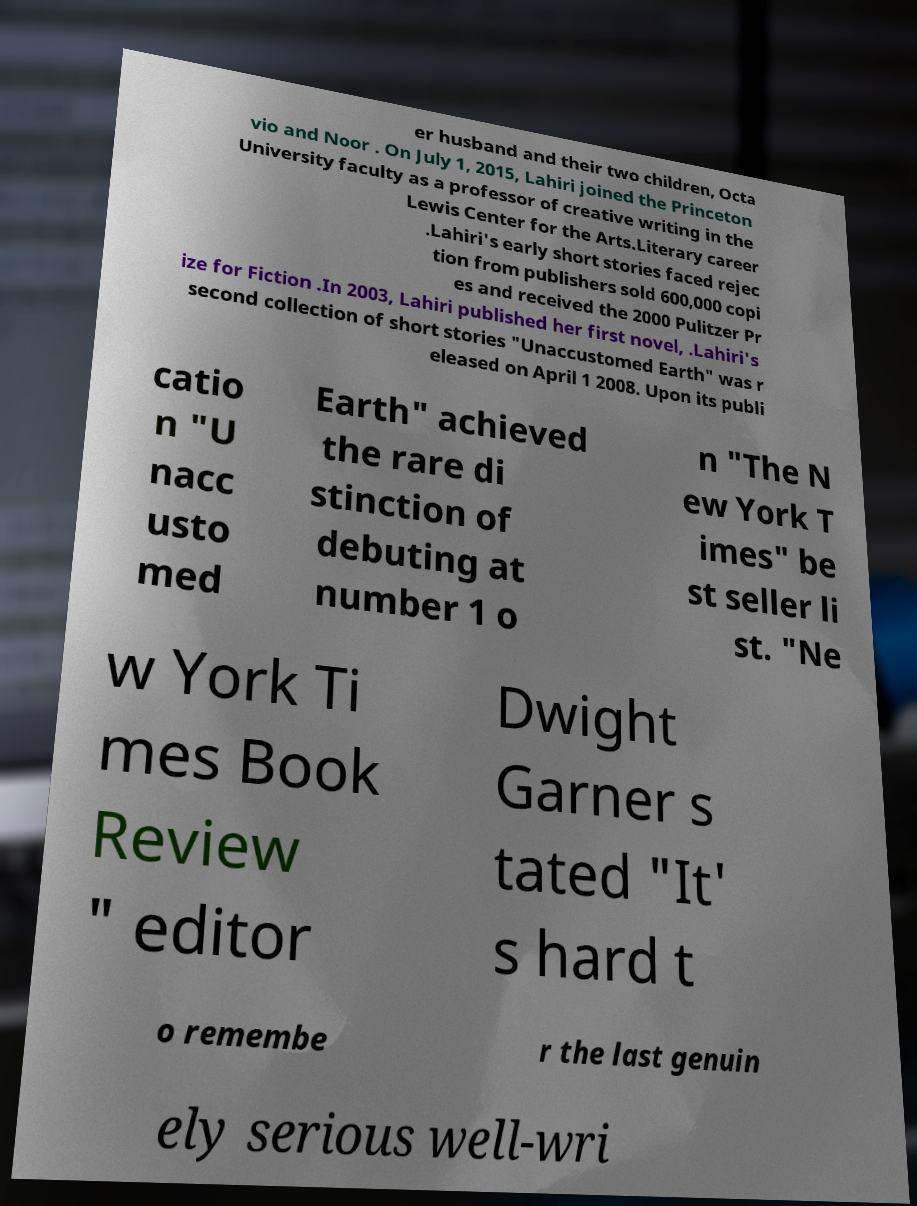Could you extract and type out the text from this image? er husband and their two children, Octa vio and Noor . On July 1, 2015, Lahiri joined the Princeton University faculty as a professor of creative writing in the Lewis Center for the Arts.Literary career .Lahiri's early short stories faced rejec tion from publishers sold 600,000 copi es and received the 2000 Pulitzer Pr ize for Fiction .In 2003, Lahiri published her first novel, .Lahiri's second collection of short stories "Unaccustomed Earth" was r eleased on April 1 2008. Upon its publi catio n "U nacc usto med Earth" achieved the rare di stinction of debuting at number 1 o n "The N ew York T imes" be st seller li st. "Ne w York Ti mes Book Review " editor Dwight Garner s tated "It' s hard t o remembe r the last genuin ely serious well-wri 